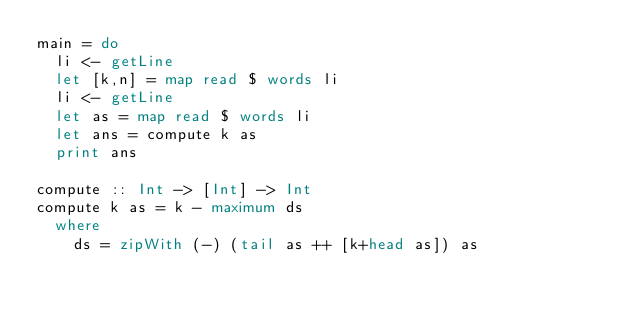Convert code to text. <code><loc_0><loc_0><loc_500><loc_500><_Haskell_>main = do
  li <- getLine
  let [k,n] = map read $ words li
  li <- getLine
  let as = map read $ words li
  let ans = compute k as
  print ans

compute :: Int -> [Int] -> Int
compute k as = k - maximum ds
  where
    ds = zipWith (-) (tail as ++ [k+head as]) as
</code> 